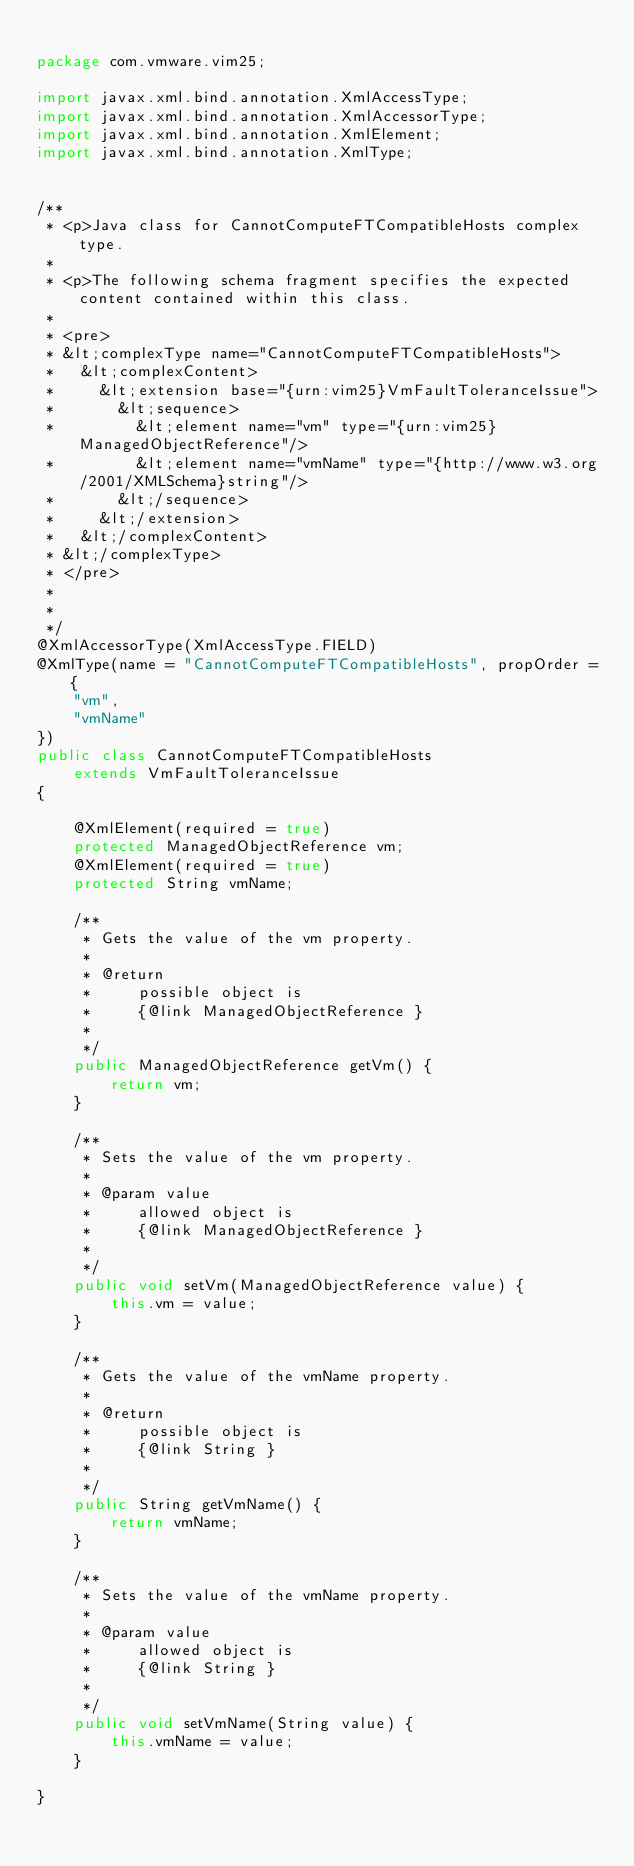Convert code to text. <code><loc_0><loc_0><loc_500><loc_500><_Java_>
package com.vmware.vim25;

import javax.xml.bind.annotation.XmlAccessType;
import javax.xml.bind.annotation.XmlAccessorType;
import javax.xml.bind.annotation.XmlElement;
import javax.xml.bind.annotation.XmlType;


/**
 * <p>Java class for CannotComputeFTCompatibleHosts complex type.
 * 
 * <p>The following schema fragment specifies the expected content contained within this class.
 * 
 * <pre>
 * &lt;complexType name="CannotComputeFTCompatibleHosts">
 *   &lt;complexContent>
 *     &lt;extension base="{urn:vim25}VmFaultToleranceIssue">
 *       &lt;sequence>
 *         &lt;element name="vm" type="{urn:vim25}ManagedObjectReference"/>
 *         &lt;element name="vmName" type="{http://www.w3.org/2001/XMLSchema}string"/>
 *       &lt;/sequence>
 *     &lt;/extension>
 *   &lt;/complexContent>
 * &lt;/complexType>
 * </pre>
 * 
 * 
 */
@XmlAccessorType(XmlAccessType.FIELD)
@XmlType(name = "CannotComputeFTCompatibleHosts", propOrder = {
    "vm",
    "vmName"
})
public class CannotComputeFTCompatibleHosts
    extends VmFaultToleranceIssue
{

    @XmlElement(required = true)
    protected ManagedObjectReference vm;
    @XmlElement(required = true)
    protected String vmName;

    /**
     * Gets the value of the vm property.
     * 
     * @return
     *     possible object is
     *     {@link ManagedObjectReference }
     *     
     */
    public ManagedObjectReference getVm() {
        return vm;
    }

    /**
     * Sets the value of the vm property.
     * 
     * @param value
     *     allowed object is
     *     {@link ManagedObjectReference }
     *     
     */
    public void setVm(ManagedObjectReference value) {
        this.vm = value;
    }

    /**
     * Gets the value of the vmName property.
     * 
     * @return
     *     possible object is
     *     {@link String }
     *     
     */
    public String getVmName() {
        return vmName;
    }

    /**
     * Sets the value of the vmName property.
     * 
     * @param value
     *     allowed object is
     *     {@link String }
     *     
     */
    public void setVmName(String value) {
        this.vmName = value;
    }

}
</code> 